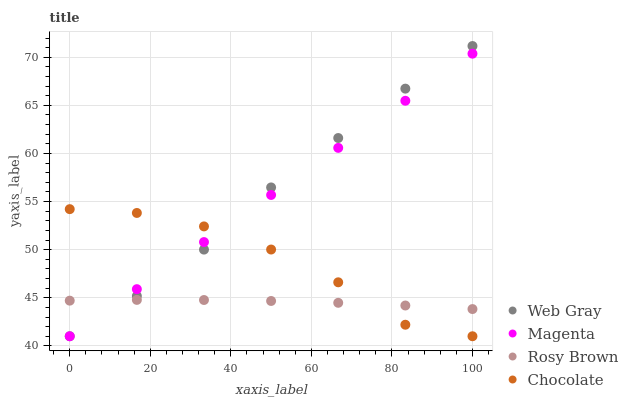Does Rosy Brown have the minimum area under the curve?
Answer yes or no. Yes. Does Web Gray have the maximum area under the curve?
Answer yes or no. Yes. Does Web Gray have the minimum area under the curve?
Answer yes or no. No. Does Rosy Brown have the maximum area under the curve?
Answer yes or no. No. Is Magenta the smoothest?
Answer yes or no. Yes. Is Chocolate the roughest?
Answer yes or no. Yes. Is Web Gray the smoothest?
Answer yes or no. No. Is Web Gray the roughest?
Answer yes or no. No. Does Magenta have the lowest value?
Answer yes or no. Yes. Does Rosy Brown have the lowest value?
Answer yes or no. No. Does Web Gray have the highest value?
Answer yes or no. Yes. Does Rosy Brown have the highest value?
Answer yes or no. No. Does Chocolate intersect Rosy Brown?
Answer yes or no. Yes. Is Chocolate less than Rosy Brown?
Answer yes or no. No. Is Chocolate greater than Rosy Brown?
Answer yes or no. No. 